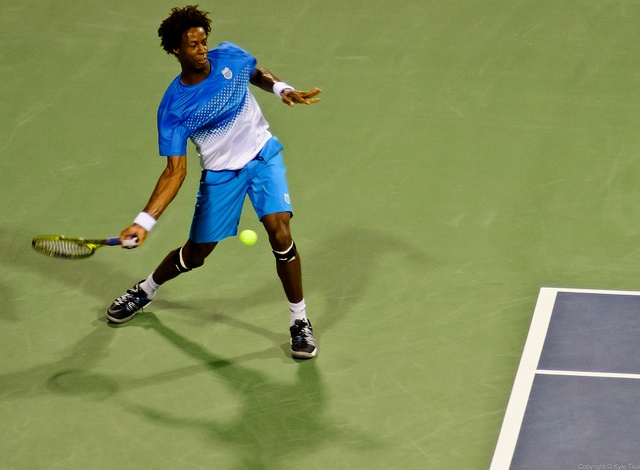Describe the objects in this image and their specific colors. I can see people in olive, black, blue, and lavender tones, tennis racket in olive and black tones, and sports ball in olive, yellow, and khaki tones in this image. 